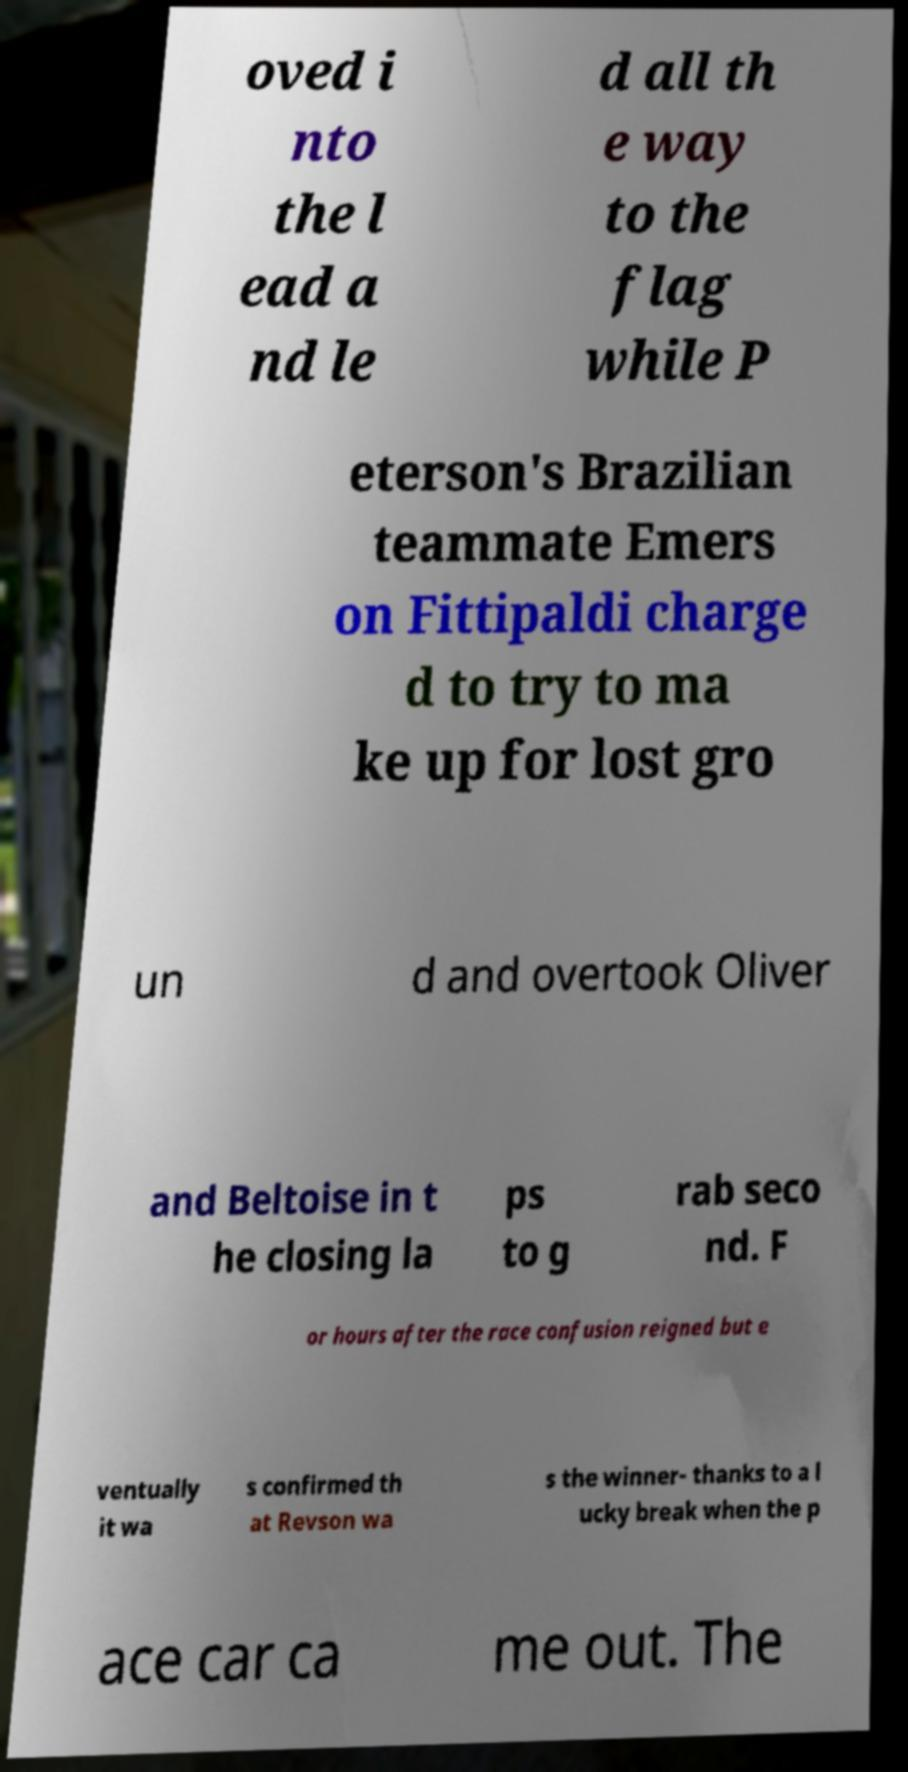There's text embedded in this image that I need extracted. Can you transcribe it verbatim? oved i nto the l ead a nd le d all th e way to the flag while P eterson's Brazilian teammate Emers on Fittipaldi charge d to try to ma ke up for lost gro un d and overtook Oliver and Beltoise in t he closing la ps to g rab seco nd. F or hours after the race confusion reigned but e ventually it wa s confirmed th at Revson wa s the winner- thanks to a l ucky break when the p ace car ca me out. The 